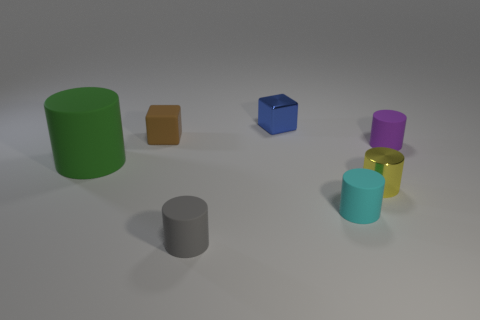Is the material of the purple object the same as the blue block?
Your answer should be very brief. No. Are there more green rubber objects that are in front of the tiny purple cylinder than big green metal things?
Give a very brief answer. Yes. What material is the cube that is behind the rubber thing behind the rubber cylinder that is to the right of the tiny metallic cylinder made of?
Your answer should be compact. Metal. How many objects are either large green cylinders or tiny cylinders on the left side of the metal block?
Provide a short and direct response. 2. Are there more matte objects in front of the green cylinder than green objects behind the small blue metal thing?
Your answer should be compact. Yes. What number of things are green matte cylinders or big brown things?
Your answer should be compact. 1. Does the metal thing behind the purple rubber object have the same size as the purple matte thing?
Your answer should be very brief. Yes. How many other objects are the same size as the cyan cylinder?
Make the answer very short. 5. Is there a tiny purple rubber thing?
Ensure brevity in your answer.  Yes. There is a metal object right of the metal object that is behind the small brown thing; what is its size?
Provide a short and direct response. Small. 